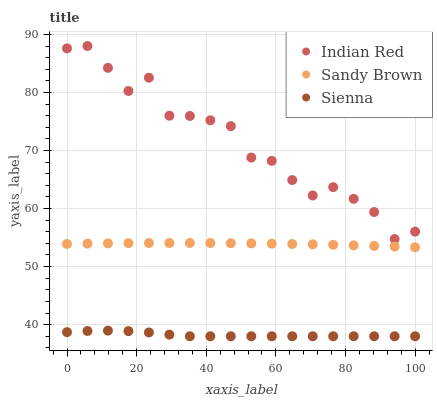Does Sienna have the minimum area under the curve?
Answer yes or no. Yes. Does Indian Red have the maximum area under the curve?
Answer yes or no. Yes. Does Sandy Brown have the minimum area under the curve?
Answer yes or no. No. Does Sandy Brown have the maximum area under the curve?
Answer yes or no. No. Is Sandy Brown the smoothest?
Answer yes or no. Yes. Is Indian Red the roughest?
Answer yes or no. Yes. Is Indian Red the smoothest?
Answer yes or no. No. Is Sandy Brown the roughest?
Answer yes or no. No. Does Sienna have the lowest value?
Answer yes or no. Yes. Does Sandy Brown have the lowest value?
Answer yes or no. No. Does Indian Red have the highest value?
Answer yes or no. Yes. Does Sandy Brown have the highest value?
Answer yes or no. No. Is Sienna less than Indian Red?
Answer yes or no. Yes. Is Sandy Brown greater than Sienna?
Answer yes or no. Yes. Does Sienna intersect Indian Red?
Answer yes or no. No. 